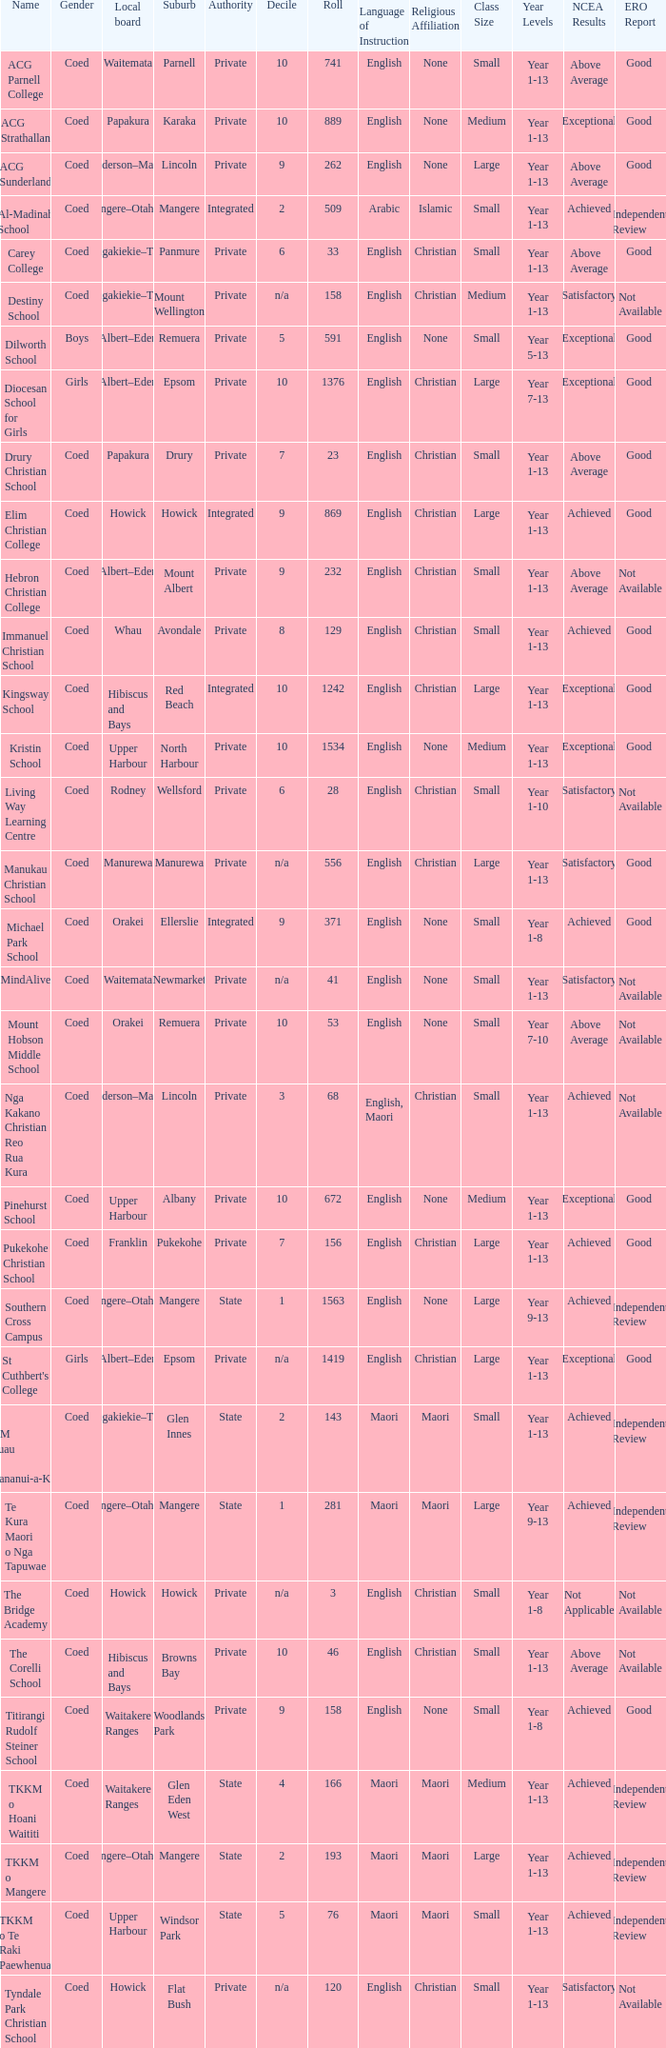What is the name when the local board is albert–eden, and a Decile of 9? Hebron Christian College. 